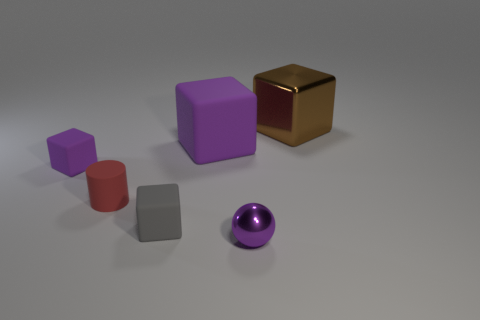Subtract all purple blocks. How many were subtracted if there are1purple blocks left? 1 Add 4 tiny green matte cylinders. How many objects exist? 10 Subtract all cylinders. How many objects are left? 5 Subtract 0 green cylinders. How many objects are left? 6 Subtract all large brown matte spheres. Subtract all small red rubber cylinders. How many objects are left? 5 Add 3 large objects. How many large objects are left? 5 Add 2 tiny balls. How many tiny balls exist? 3 